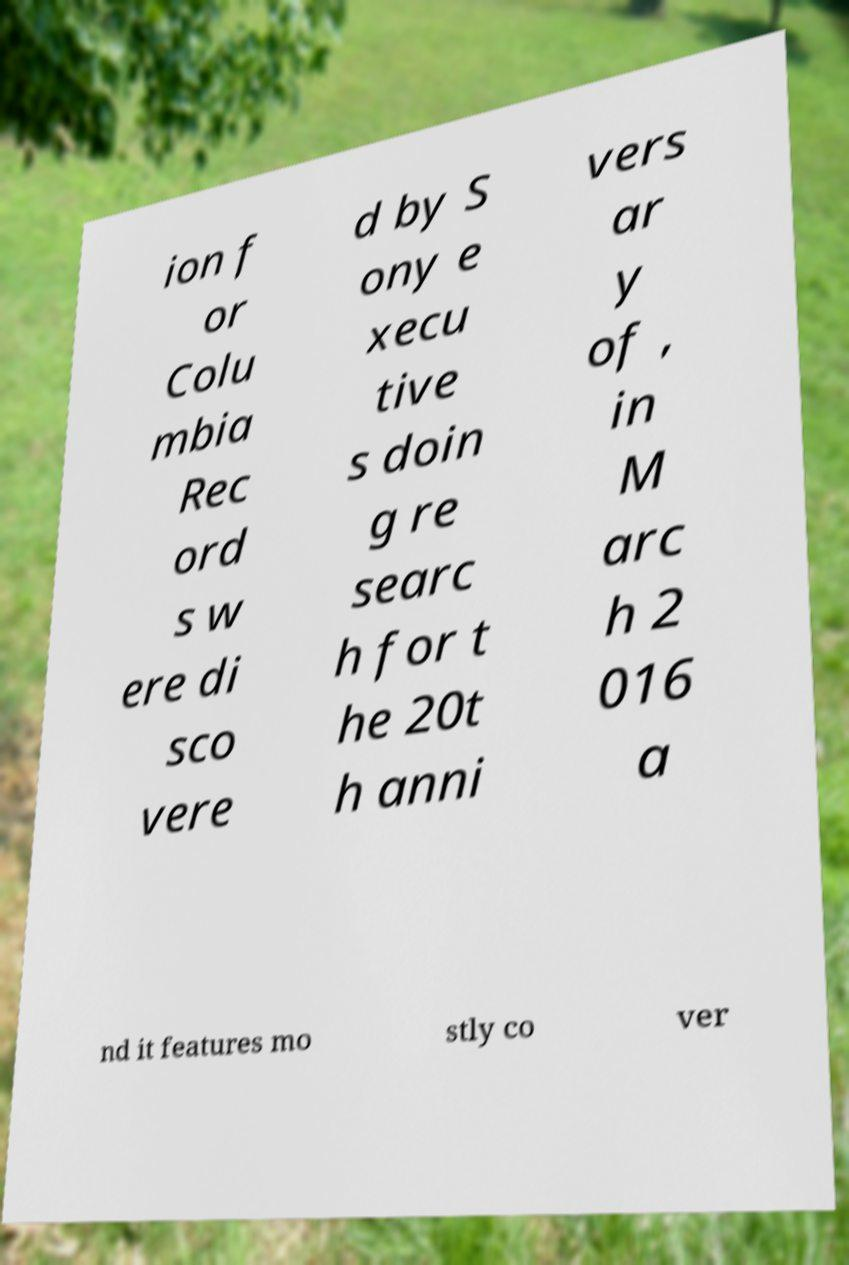What messages or text are displayed in this image? I need them in a readable, typed format. ion f or Colu mbia Rec ord s w ere di sco vere d by S ony e xecu tive s doin g re searc h for t he 20t h anni vers ar y of , in M arc h 2 016 a nd it features mo stly co ver 